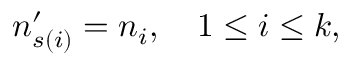Convert formula to latex. <formula><loc_0><loc_0><loc_500><loc_500>n _ { s ( i ) } ^ { \prime } = n _ { i } , \quad 1 \leq i \leq k ,</formula> 